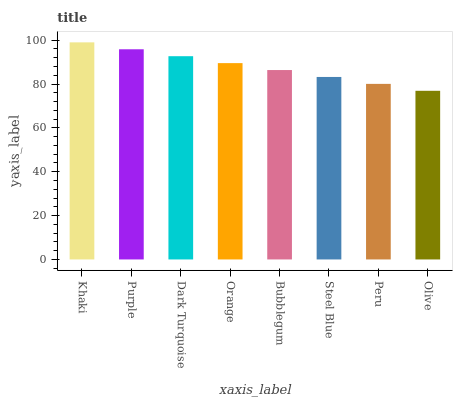Is Olive the minimum?
Answer yes or no. Yes. Is Khaki the maximum?
Answer yes or no. Yes. Is Purple the minimum?
Answer yes or no. No. Is Purple the maximum?
Answer yes or no. No. Is Khaki greater than Purple?
Answer yes or no. Yes. Is Purple less than Khaki?
Answer yes or no. Yes. Is Purple greater than Khaki?
Answer yes or no. No. Is Khaki less than Purple?
Answer yes or no. No. Is Orange the high median?
Answer yes or no. Yes. Is Bubblegum the low median?
Answer yes or no. Yes. Is Olive the high median?
Answer yes or no. No. Is Olive the low median?
Answer yes or no. No. 